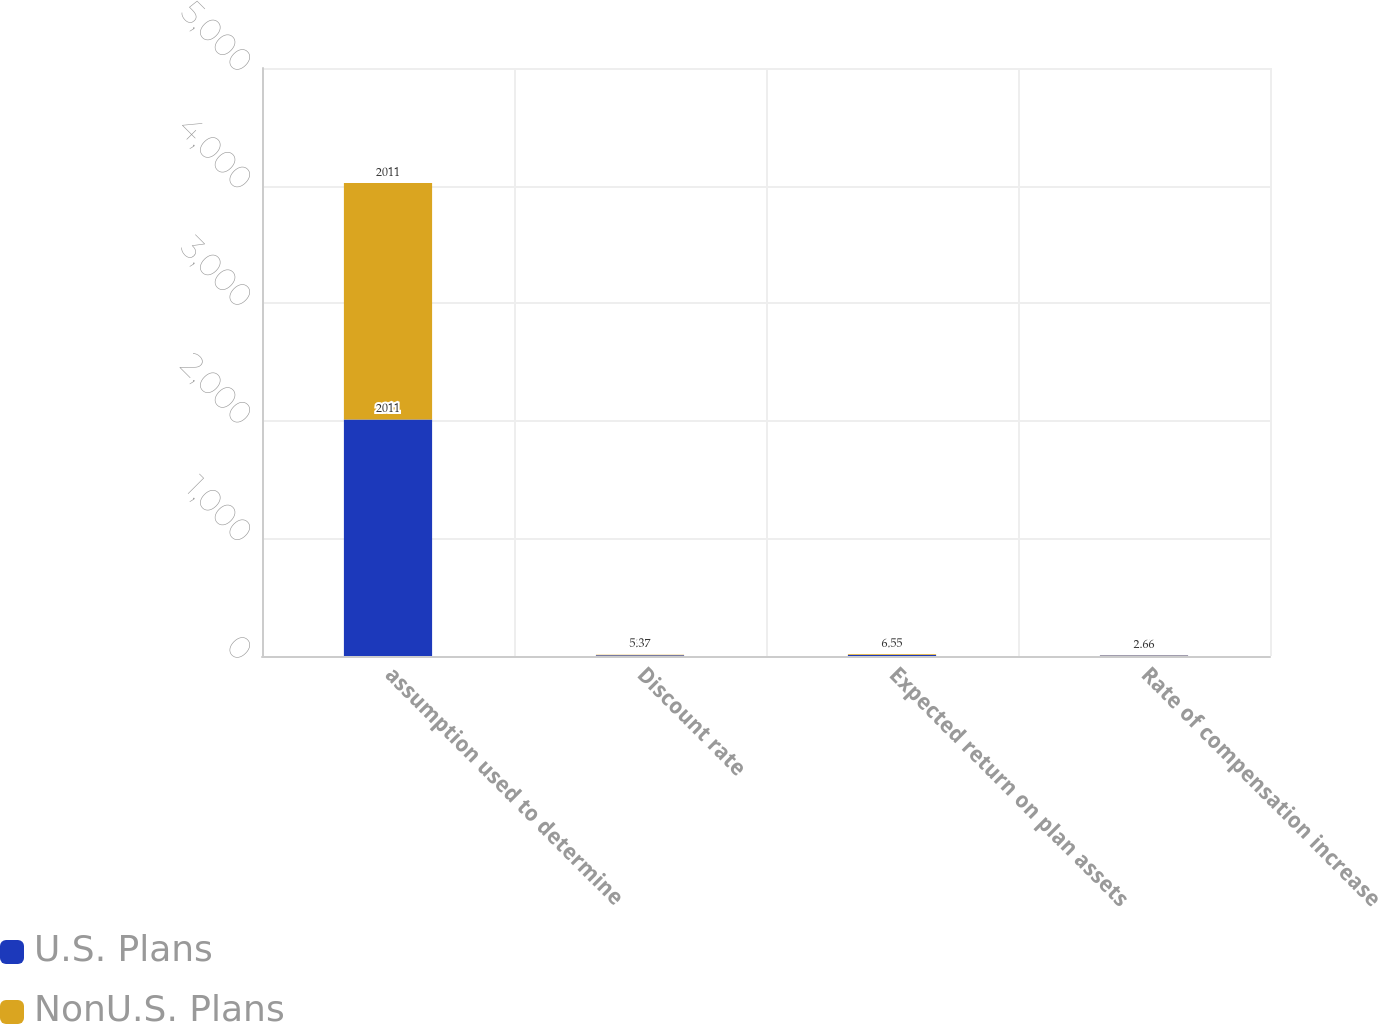Convert chart to OTSL. <chart><loc_0><loc_0><loc_500><loc_500><stacked_bar_chart><ecel><fcel>assumption used to determine<fcel>Discount rate<fcel>Expected return on plan assets<fcel>Rate of compensation increase<nl><fcel>U.S. Plans<fcel>2011<fcel>5.6<fcel>7.75<fcel>3.25<nl><fcel>NonU.S. Plans<fcel>2011<fcel>5.37<fcel>6.55<fcel>2.66<nl></chart> 